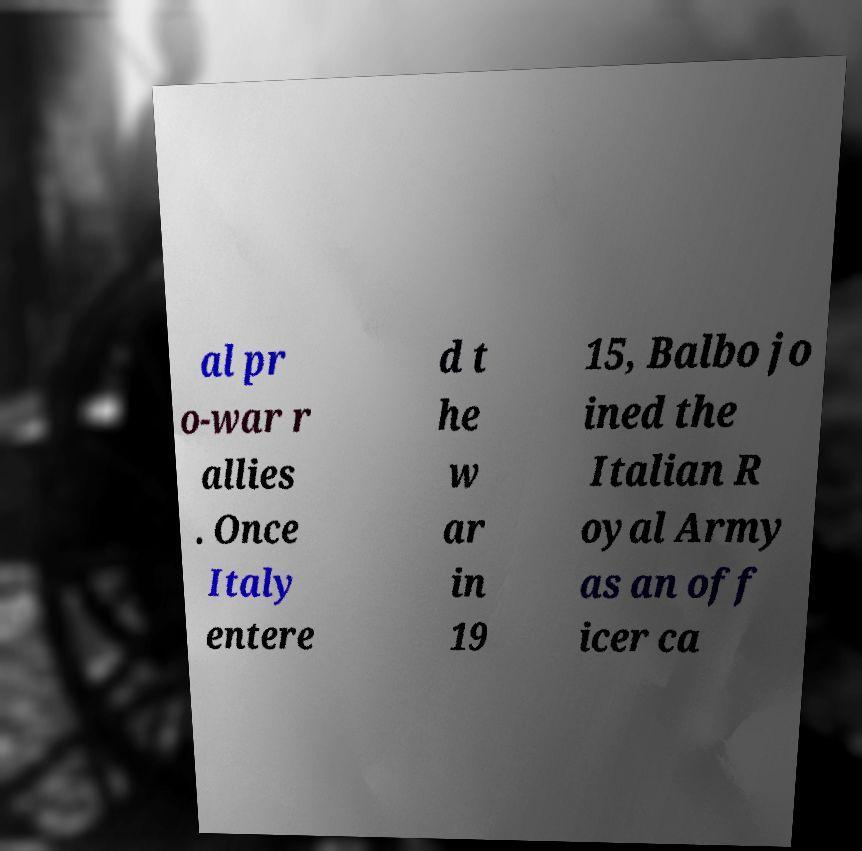I need the written content from this picture converted into text. Can you do that? al pr o-war r allies . Once Italy entere d t he w ar in 19 15, Balbo jo ined the Italian R oyal Army as an off icer ca 